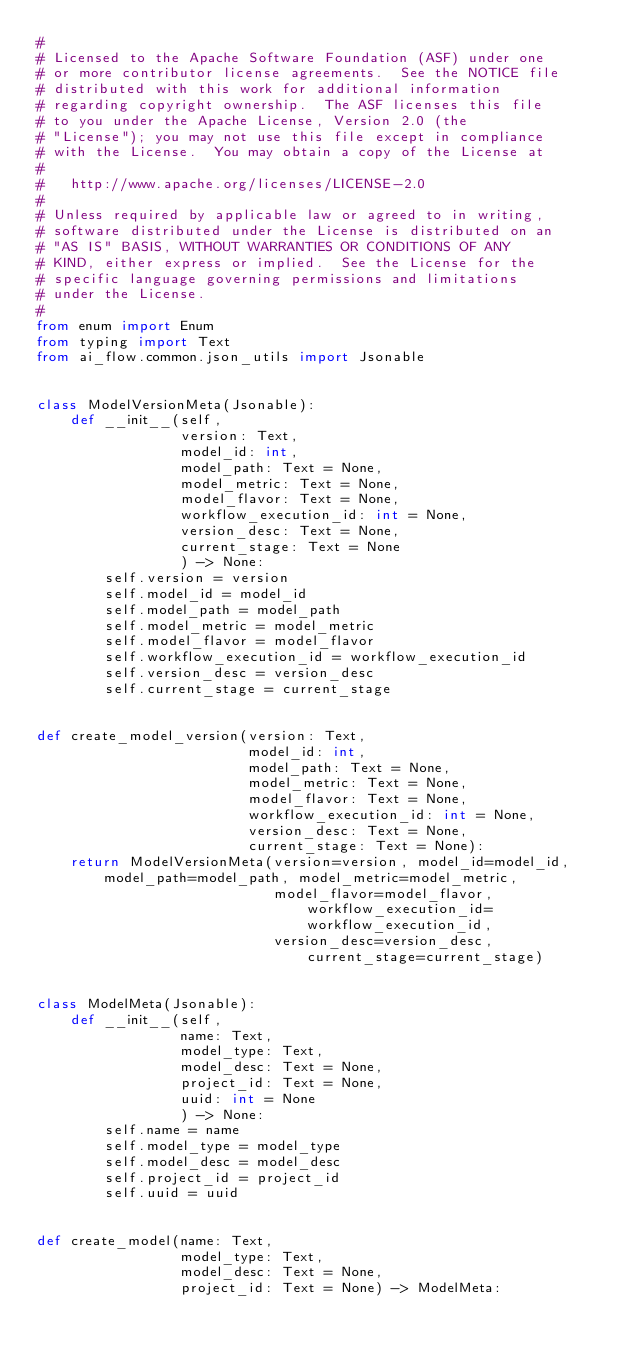<code> <loc_0><loc_0><loc_500><loc_500><_Python_>#
# Licensed to the Apache Software Foundation (ASF) under one
# or more contributor license agreements.  See the NOTICE file
# distributed with this work for additional information
# regarding copyright ownership.  The ASF licenses this file
# to you under the Apache License, Version 2.0 (the
# "License"); you may not use this file except in compliance
# with the License.  You may obtain a copy of the License at
#
#   http://www.apache.org/licenses/LICENSE-2.0
#
# Unless required by applicable law or agreed to in writing,
# software distributed under the License is distributed on an
# "AS IS" BASIS, WITHOUT WARRANTIES OR CONDITIONS OF ANY
# KIND, either express or implied.  See the License for the
# specific language governing permissions and limitations
# under the License.
#
from enum import Enum
from typing import Text
from ai_flow.common.json_utils import Jsonable


class ModelVersionMeta(Jsonable):
    def __init__(self,
                 version: Text,
                 model_id: int,
                 model_path: Text = None,
                 model_metric: Text = None,
                 model_flavor: Text = None,
                 workflow_execution_id: int = None,
                 version_desc: Text = None,
                 current_stage: Text = None
                 ) -> None:
        self.version = version
        self.model_id = model_id
        self.model_path = model_path
        self.model_metric = model_metric
        self.model_flavor = model_flavor
        self.workflow_execution_id = workflow_execution_id
        self.version_desc = version_desc
        self.current_stage = current_stage


def create_model_version(version: Text,
                         model_id: int,
                         model_path: Text = None,
                         model_metric: Text = None,
                         model_flavor: Text = None,
                         workflow_execution_id: int = None,
                         version_desc: Text = None,
                         current_stage: Text = None):
    return ModelVersionMeta(version=version, model_id=model_id, model_path=model_path, model_metric=model_metric,
                            model_flavor=model_flavor, workflow_execution_id=workflow_execution_id,
                            version_desc=version_desc, current_stage=current_stage)


class ModelMeta(Jsonable):
    def __init__(self,
                 name: Text,
                 model_type: Text,
                 model_desc: Text = None,
                 project_id: Text = None,
                 uuid: int = None
                 ) -> None:
        self.name = name
        self.model_type = model_type
        self.model_desc = model_desc
        self.project_id = project_id
        self.uuid = uuid


def create_model(name: Text,
                 model_type: Text,
                 model_desc: Text = None,
                 project_id: Text = None) -> ModelMeta:</code> 